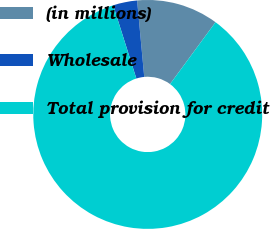Convert chart. <chart><loc_0><loc_0><loc_500><loc_500><pie_chart><fcel>(in millions)<fcel>Wholesale<fcel>Total provision for credit<nl><fcel>11.57%<fcel>3.4%<fcel>85.03%<nl></chart> 